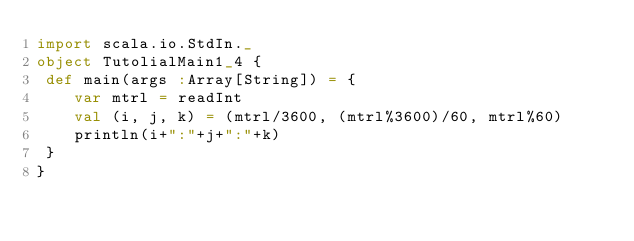<code> <loc_0><loc_0><loc_500><loc_500><_Scala_>import scala.io.StdIn._
object TutolialMain1_4 {
 def main(args :Array[String]) = {
	var mtrl = readInt
	val (i, j, k) = (mtrl/3600, (mtrl%3600)/60, mtrl%60)
	println(i+":"+j+":"+k)
 }
}</code> 